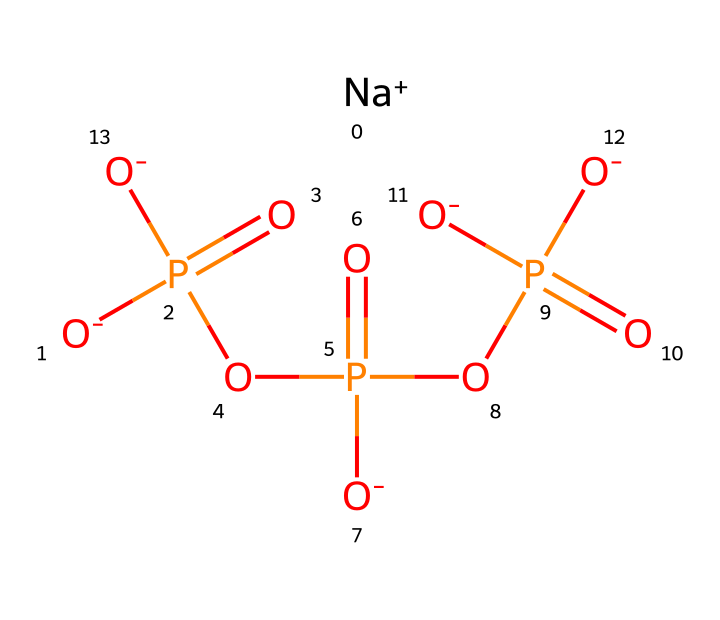How many sodium ions are present in this compound? The structure includes one sodium ion ([Na+]), which can be identified from the SMILES representation. By examining the ions in the chemical structure, it’s clear there is just one sodium ion linked to the anionic part.
Answer: 1 What type of chemical is sodium polyphosphate? Sodium polyphosphate is classified as a polyphosphate, which can be determined by the presence of multiple phosphate units in its structure. The repeating phosphate units denote it as a polyphosphate, specifically a type of sequestering agent.
Answer: polyphosphate How many phosphorus atoms are in sodium polyphosphate? By analyzing the SMILES representation, there are three identifiable phosphorus atoms, each shown in the phosphate groups that are part of the polyphosphate chain. Counting these gives a total of three phosphorus atoms.
Answer: 3 What functional groups are present in sodium polyphosphate? The structure contains phosphate groups (identified as P(=O)(O-)), which reveal the presence of functional groups relevant to its properties as a sequestering agent. The negative charges also indicate the presence of functional groups that interact with metal ions like lead.
Answer: phosphate groups What is the charge of the sodium ion in this chemical? From the SMILES notation, the sodium ion is represented as [Na+], indicating a positive charge. This reflects the behavior of sodium in solution, where it presents as a cation.
Answer: +1 How many oxygen atoms are present in sodium polyphosphate? The SMILES notation features several oxygens represented in the phosphate groups, providing a total of eight oxygen atoms when counted from the SMILES representation. This includes those in the anionic parts of the phosphates.
Answer: 8 What role does sodium polyphosphate play in water treatment? Sodium polyphosphate acts as a sequestering agent that binds to lead ions in water, preventing lead precipitation and facilitating its removal. This function is crucial in treating lead pollution effectively.
Answer: sequestering agent 